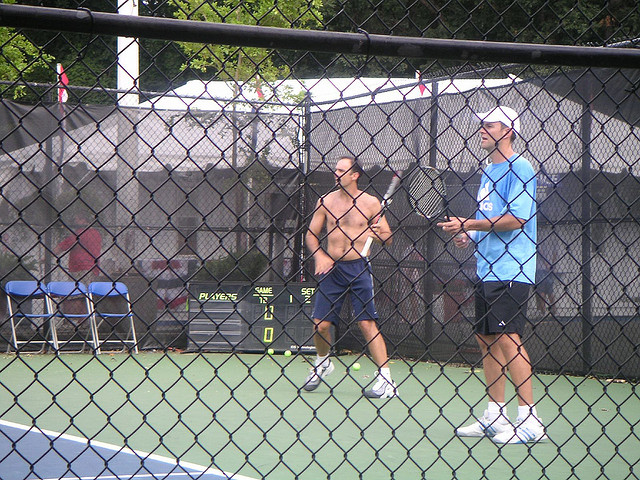How many men are wearing hats? 1 